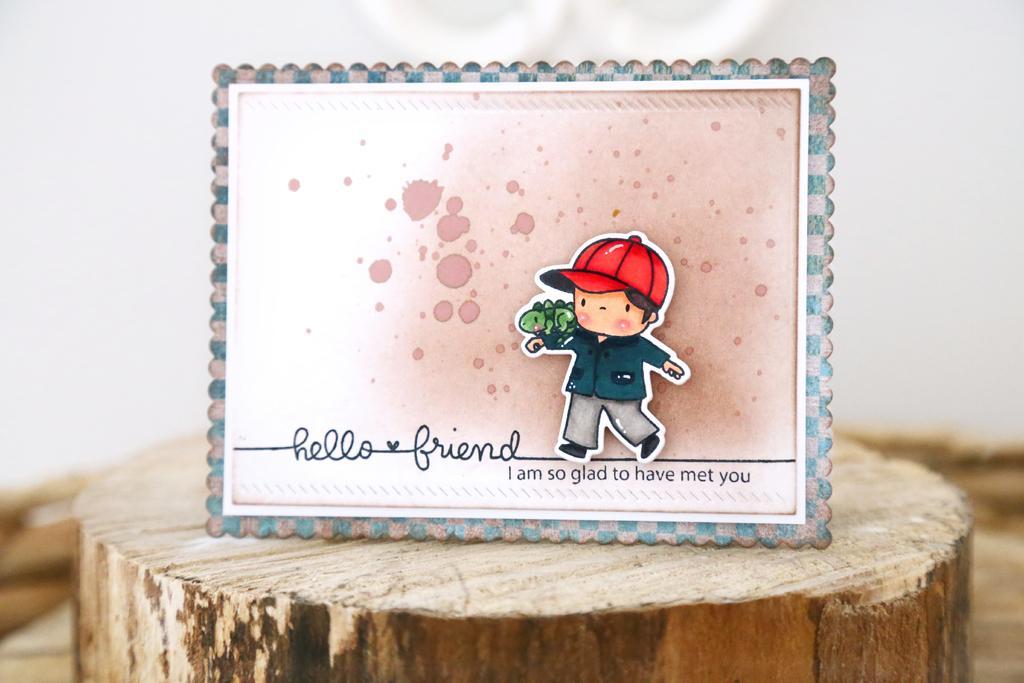Please provide a concise description of this image. In the center of the image we can see greeting placed on the wood. 